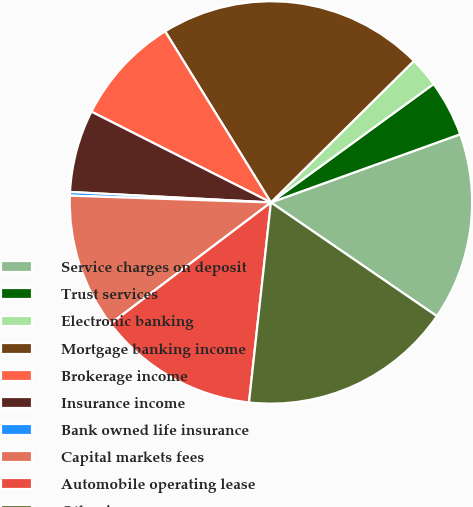<chart> <loc_0><loc_0><loc_500><loc_500><pie_chart><fcel>Service charges on deposit<fcel>Trust services<fcel>Electronic banking<fcel>Mortgage banking income<fcel>Brokerage income<fcel>Insurance income<fcel>Bank owned life insurance<fcel>Capital markets fees<fcel>Automobile operating lease<fcel>Other income<nl><fcel>15.06%<fcel>4.51%<fcel>2.4%<fcel>21.39%<fcel>8.73%<fcel>6.62%<fcel>0.29%<fcel>10.84%<fcel>12.95%<fcel>17.17%<nl></chart> 